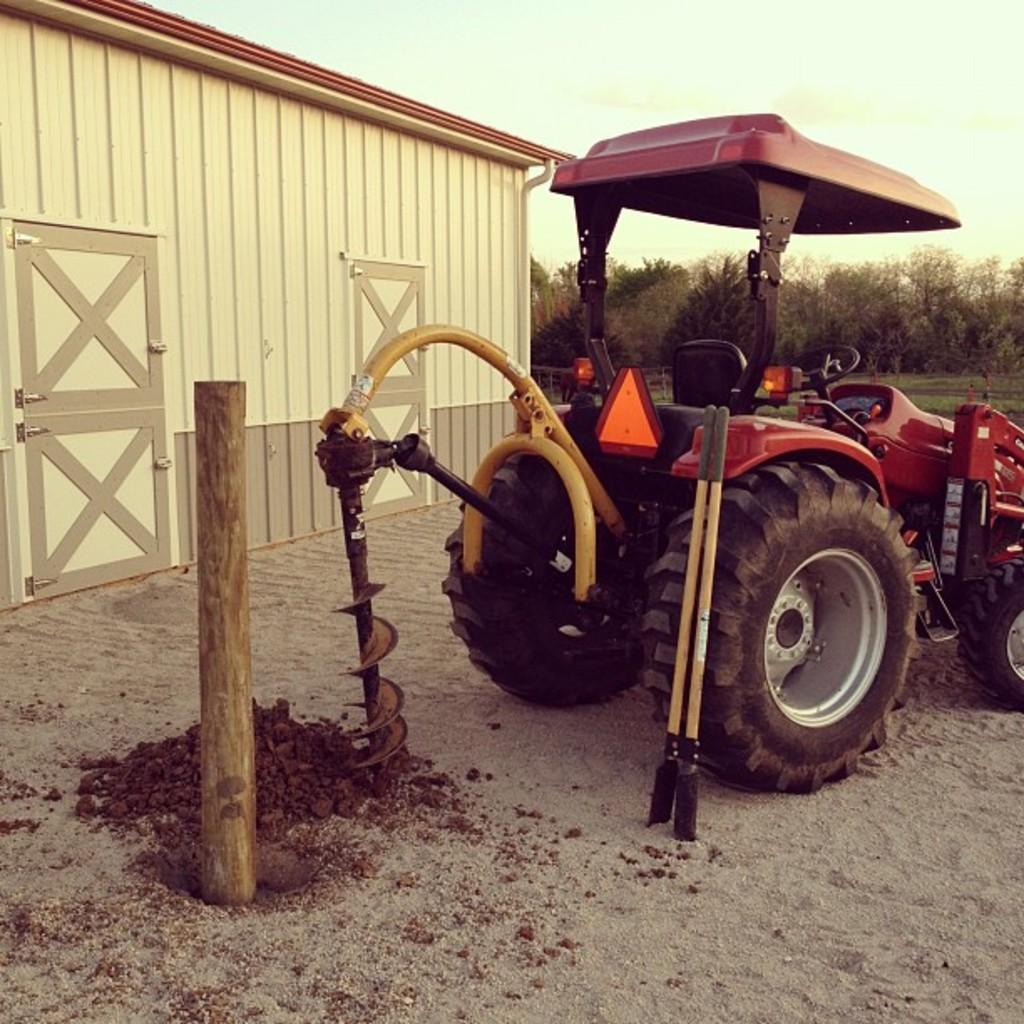Please provide a concise description of this image. In the image we can see a vehicle, pole and the sand. Here we can see the storage room, trees and the sky. 